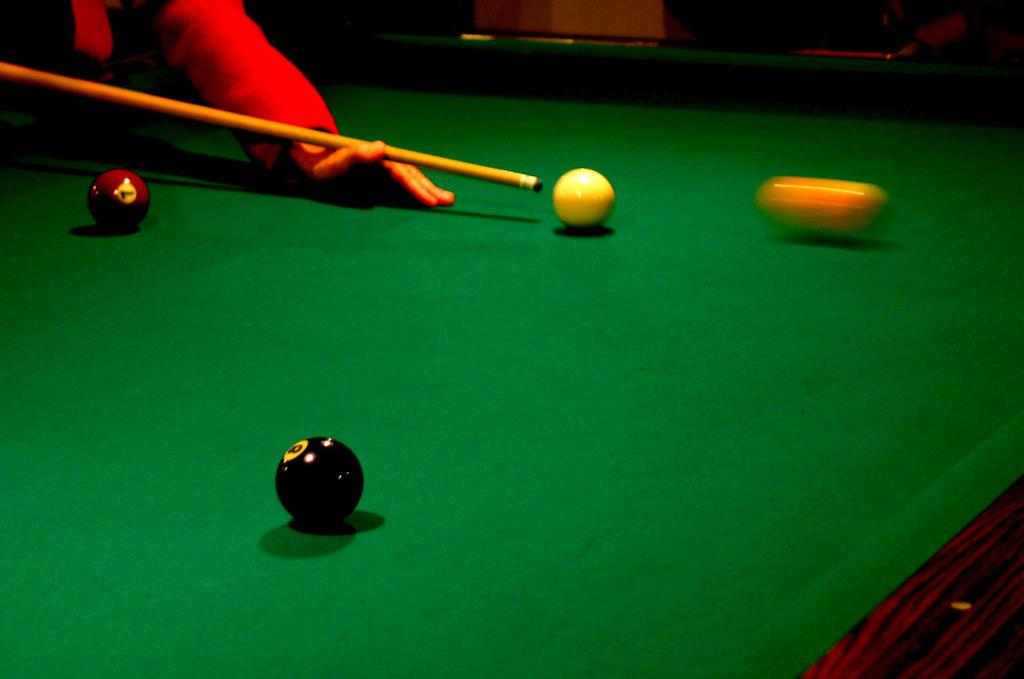Who or what is present in the image? There is a person in the image. What is the person doing with their hand? The person's hand is on the table. What objects can be seen in the image besides the person? There are balls and a stick in the image. What type of noise can be heard coming from the cat in the image? There is no cat present in the image, so it is not possible to determine what noise it might make. 